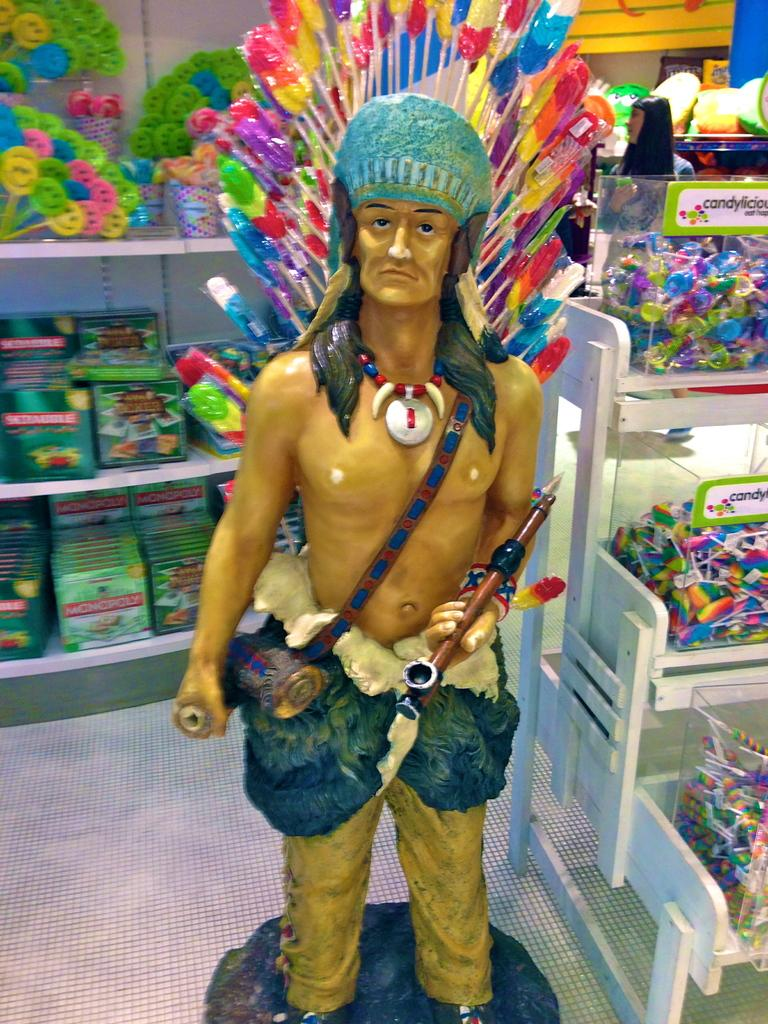What is the main subject of the image? There is a sculpture in the image. What can be seen beneath the sculpture? The image shows a floor. What is present near the sculpture? There is a rack in the image. What is on the rack? There are food items on the rack. What can be seen in the background of the image? There are books and smiley sticks visible in the background of the image. Is there a volleyball game taking place in the image? There is no volleyball game present in the image. What type of shade is being provided by the sculpture in the image? The sculpture does not provide any shade in the image, as it is a stationary object. 